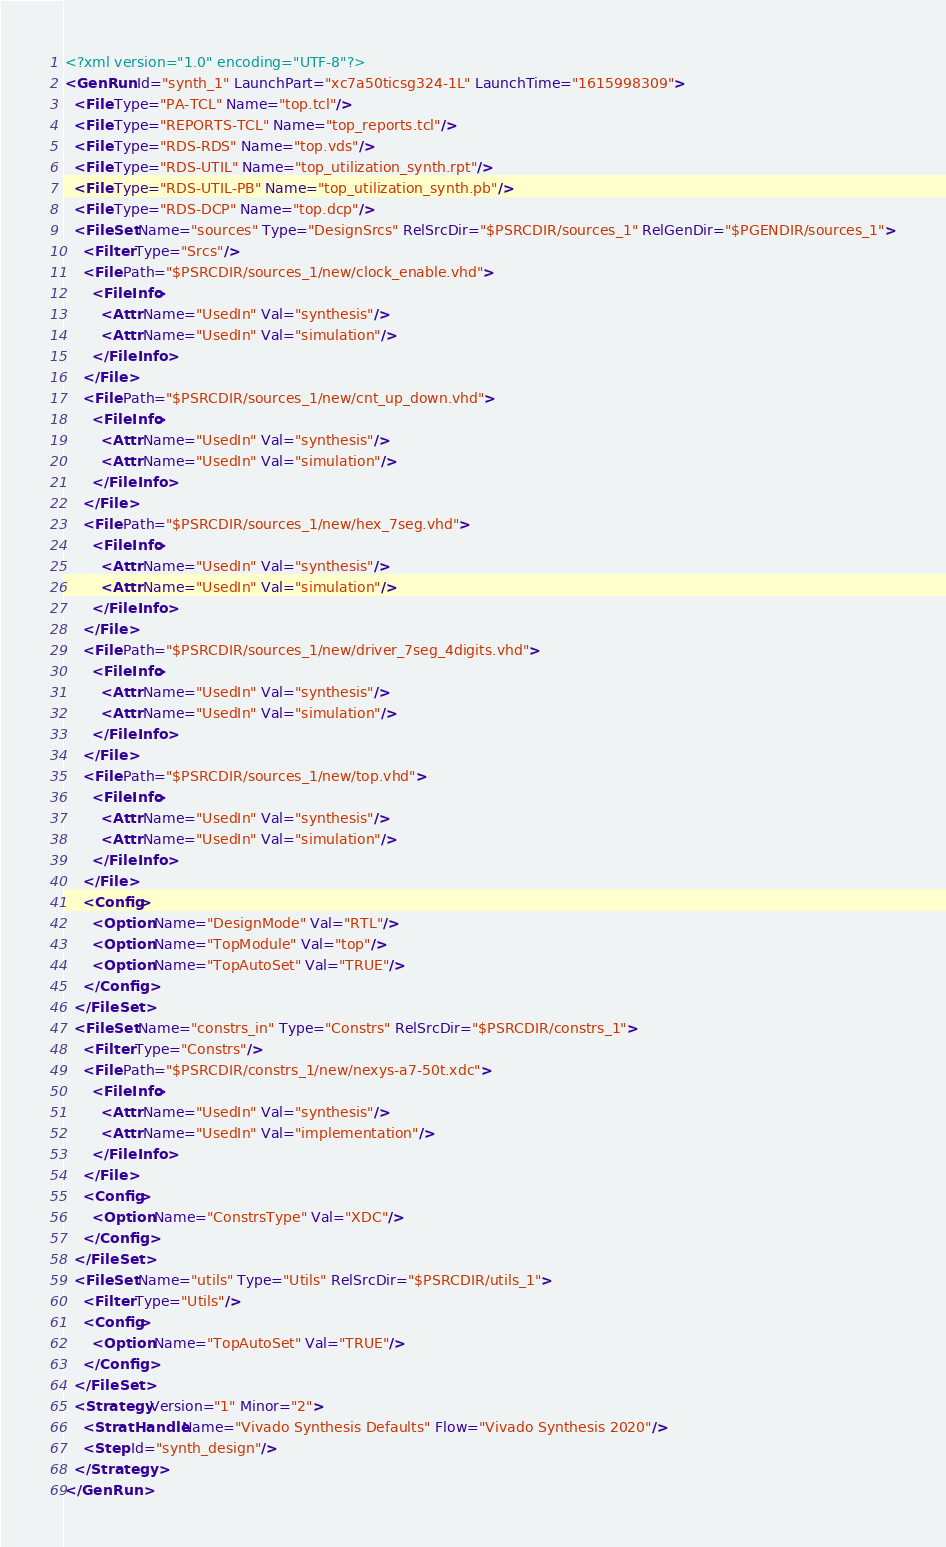<code> <loc_0><loc_0><loc_500><loc_500><_XML_><?xml version="1.0" encoding="UTF-8"?>
<GenRun Id="synth_1" LaunchPart="xc7a50ticsg324-1L" LaunchTime="1615998309">
  <File Type="PA-TCL" Name="top.tcl"/>
  <File Type="REPORTS-TCL" Name="top_reports.tcl"/>
  <File Type="RDS-RDS" Name="top.vds"/>
  <File Type="RDS-UTIL" Name="top_utilization_synth.rpt"/>
  <File Type="RDS-UTIL-PB" Name="top_utilization_synth.pb"/>
  <File Type="RDS-DCP" Name="top.dcp"/>
  <FileSet Name="sources" Type="DesignSrcs" RelSrcDir="$PSRCDIR/sources_1" RelGenDir="$PGENDIR/sources_1">
    <Filter Type="Srcs"/>
    <File Path="$PSRCDIR/sources_1/new/clock_enable.vhd">
      <FileInfo>
        <Attr Name="UsedIn" Val="synthesis"/>
        <Attr Name="UsedIn" Val="simulation"/>
      </FileInfo>
    </File>
    <File Path="$PSRCDIR/sources_1/new/cnt_up_down.vhd">
      <FileInfo>
        <Attr Name="UsedIn" Val="synthesis"/>
        <Attr Name="UsedIn" Val="simulation"/>
      </FileInfo>
    </File>
    <File Path="$PSRCDIR/sources_1/new/hex_7seg.vhd">
      <FileInfo>
        <Attr Name="UsedIn" Val="synthesis"/>
        <Attr Name="UsedIn" Val="simulation"/>
      </FileInfo>
    </File>
    <File Path="$PSRCDIR/sources_1/new/driver_7seg_4digits.vhd">
      <FileInfo>
        <Attr Name="UsedIn" Val="synthesis"/>
        <Attr Name="UsedIn" Val="simulation"/>
      </FileInfo>
    </File>
    <File Path="$PSRCDIR/sources_1/new/top.vhd">
      <FileInfo>
        <Attr Name="UsedIn" Val="synthesis"/>
        <Attr Name="UsedIn" Val="simulation"/>
      </FileInfo>
    </File>
    <Config>
      <Option Name="DesignMode" Val="RTL"/>
      <Option Name="TopModule" Val="top"/>
      <Option Name="TopAutoSet" Val="TRUE"/>
    </Config>
  </FileSet>
  <FileSet Name="constrs_in" Type="Constrs" RelSrcDir="$PSRCDIR/constrs_1">
    <Filter Type="Constrs"/>
    <File Path="$PSRCDIR/constrs_1/new/nexys-a7-50t.xdc">
      <FileInfo>
        <Attr Name="UsedIn" Val="synthesis"/>
        <Attr Name="UsedIn" Val="implementation"/>
      </FileInfo>
    </File>
    <Config>
      <Option Name="ConstrsType" Val="XDC"/>
    </Config>
  </FileSet>
  <FileSet Name="utils" Type="Utils" RelSrcDir="$PSRCDIR/utils_1">
    <Filter Type="Utils"/>
    <Config>
      <Option Name="TopAutoSet" Val="TRUE"/>
    </Config>
  </FileSet>
  <Strategy Version="1" Minor="2">
    <StratHandle Name="Vivado Synthesis Defaults" Flow="Vivado Synthesis 2020"/>
    <Step Id="synth_design"/>
  </Strategy>
</GenRun>
</code> 